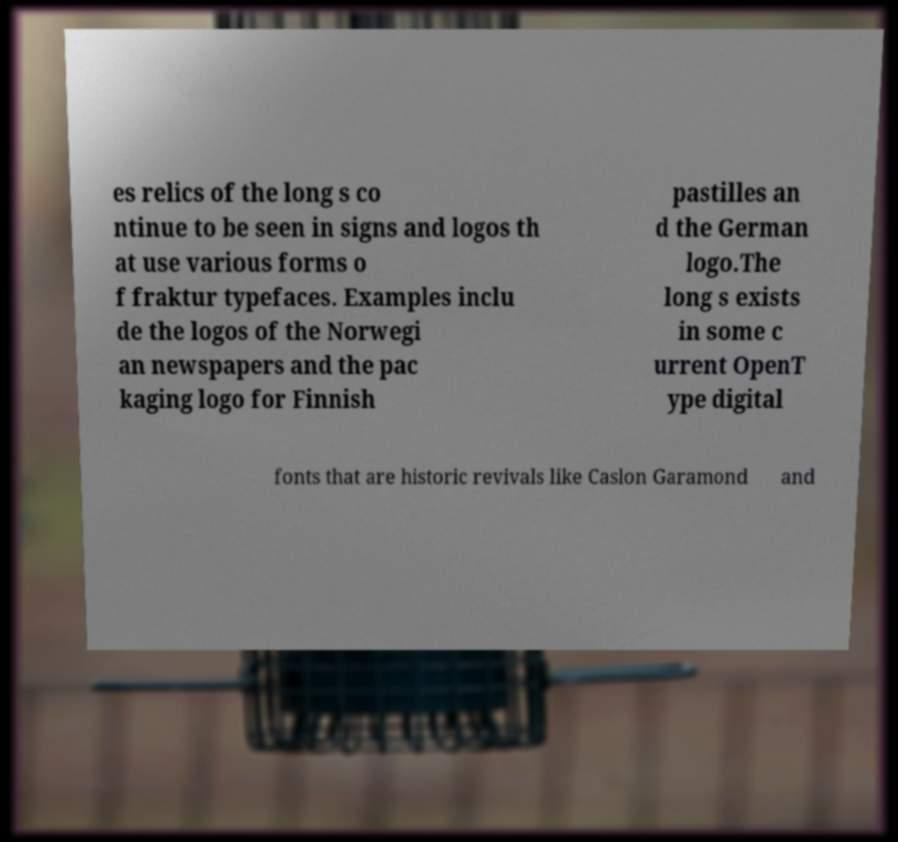There's text embedded in this image that I need extracted. Can you transcribe it verbatim? es relics of the long s co ntinue to be seen in signs and logos th at use various forms o f fraktur typefaces. Examples inclu de the logos of the Norwegi an newspapers and the pac kaging logo for Finnish pastilles an d the German logo.The long s exists in some c urrent OpenT ype digital fonts that are historic revivals like Caslon Garamond and 